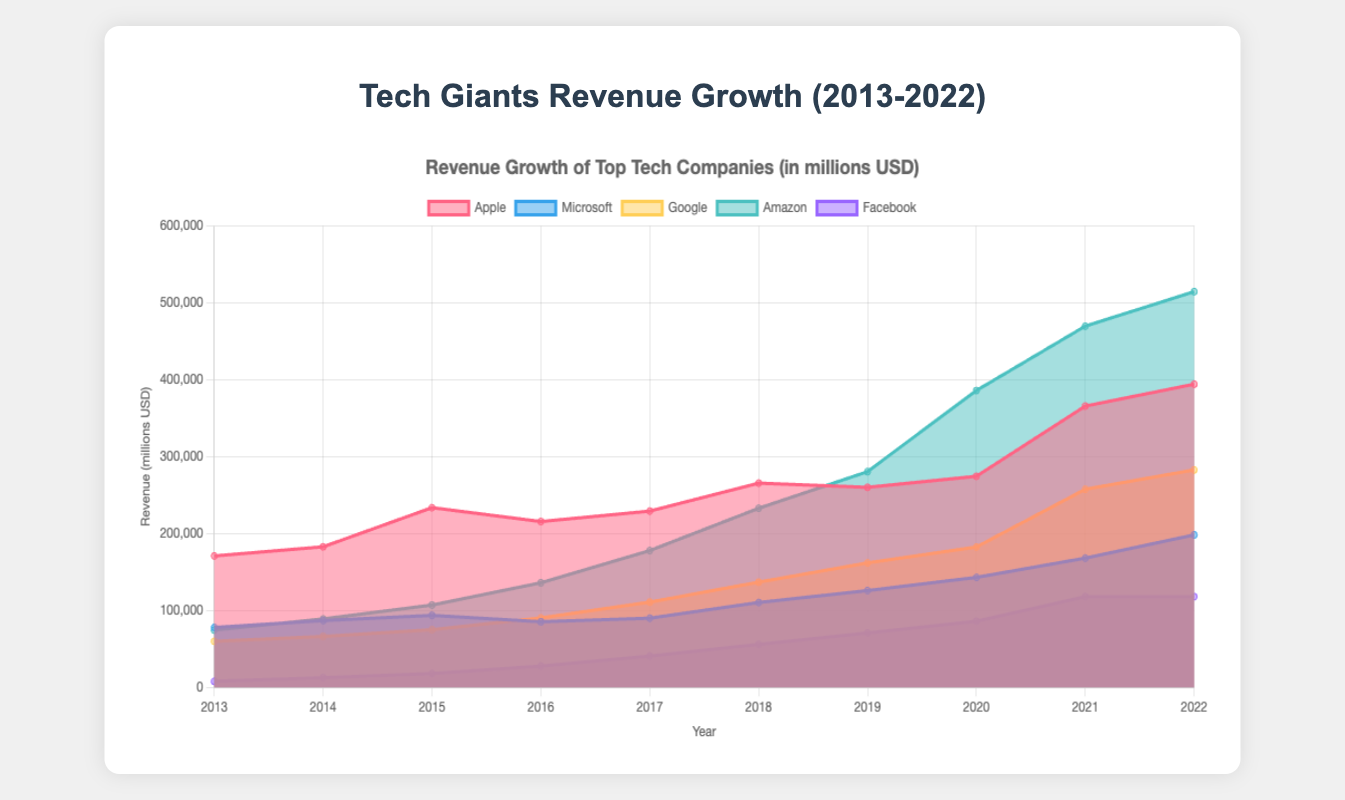What is the title of the chart? The title is usually located at the top of the chart, and indicates what the chart is about. Here, the title clearly states the focus on revenue growth.
Answer: Tech Giants Revenue Growth (2013-2022) How many companies are represented in the chart? Each dataset in the chart represents a company, and there are five different datasets (Apple, Microsoft, Google, Amazon, Facebook).
Answer: Five Which company had the highest revenue in 2022? By looking at the endpoint of each line representing 2022, we can see that Amazon's line is the highest.
Answer: Amazon What was the approximate revenue of Google in 2017? Locate the point for Google on the 2017 axis and see its value on the y-axis, which is slightly over 110,000.
Answer: About 110,855 million USD Compare the revenue growth of Apple and Facebook from 2013 to 2022. Look at the starting and ending points of both Apple and Facebook lines from 2013 to 2022. Apple started at 170,910 and ended at 394,328, while Facebook started at 7,872 and ended at 117,929.
Answer: Apple grew from 170,910 to 394,328, and Facebook grew from 7,872 to 117,929 Which company had the most consistent year-over-year revenue growth? By observing the smoothest line without sudden spikes or drops, Microsoft's line appears the most consistent.
Answer: Microsoft In which year did Amazon surpass $200,000 million USD in revenue? Check the point on Amazon's line where it first crosses the 200,000 mark on the y-axis.
Answer: 2018 Between 2015 and 2016, did Google or Microsoft have a higher percentage increase in revenue? Calculate percentage increase for both: Google: (90272-74989)/74989 ≈ 20.4%, Microsoft: (85320-93580)/93580 ≈ -8.8%. Google has a higher percentage increase.
Answer: Google What is the cumulative revenue of all companies combined in 2020? Add the revenues of Apple, Microsoft, Google, Amazon, and Facebook for 2020: 274515 + 143015 + 182527 + 386064 + 85965 = 1072086 million USD.
Answer: 1072086 million USD 